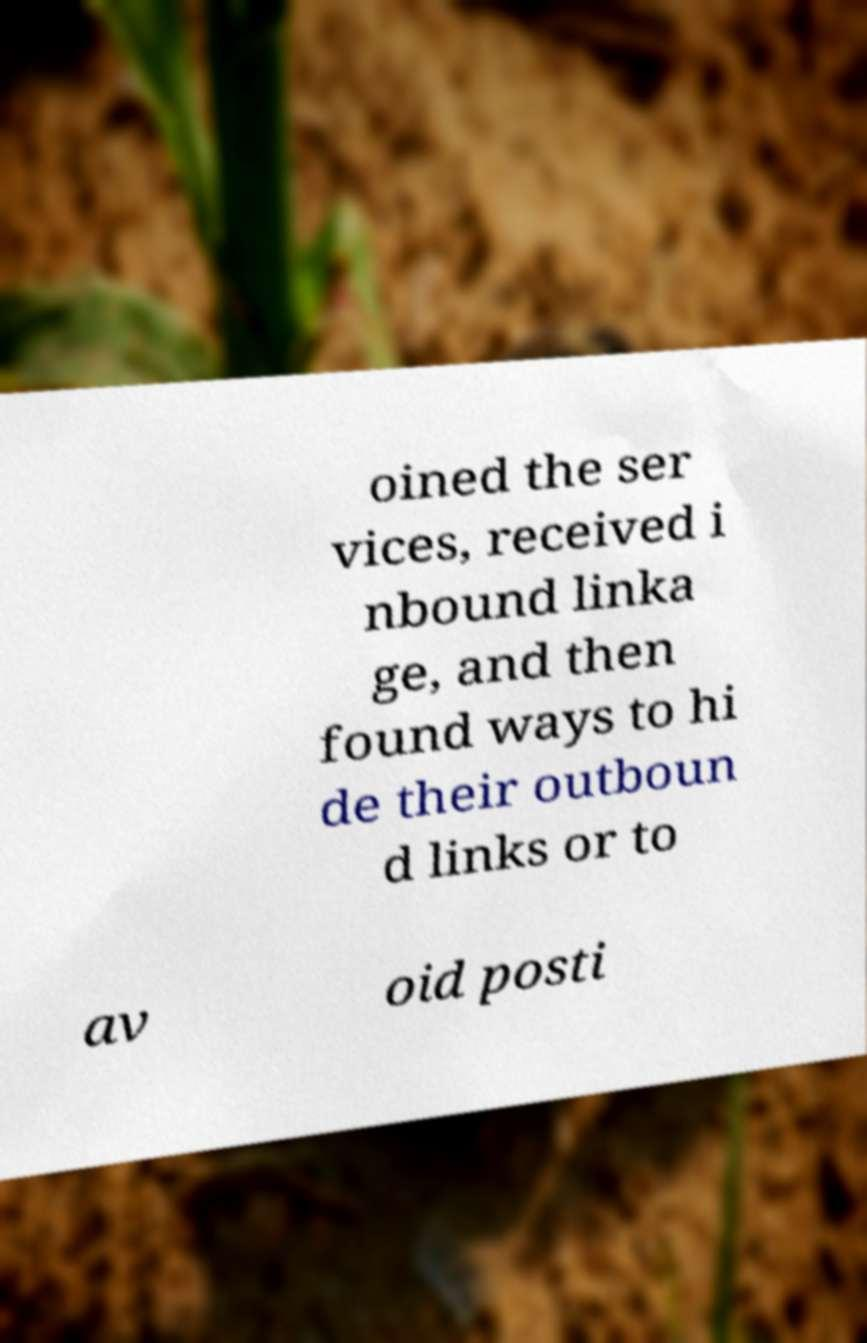Could you assist in decoding the text presented in this image and type it out clearly? oined the ser vices, received i nbound linka ge, and then found ways to hi de their outboun d links or to av oid posti 